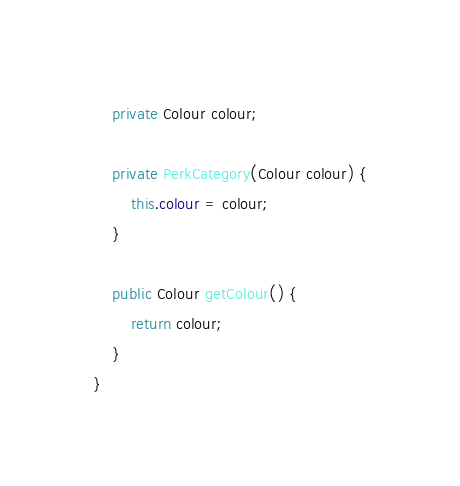<code> <loc_0><loc_0><loc_500><loc_500><_Java_>
	private Colour colour;

	private PerkCategory(Colour colour) {
		this.colour = colour;
	}

	public Colour getColour() {
		return colour;
	}
}
</code> 